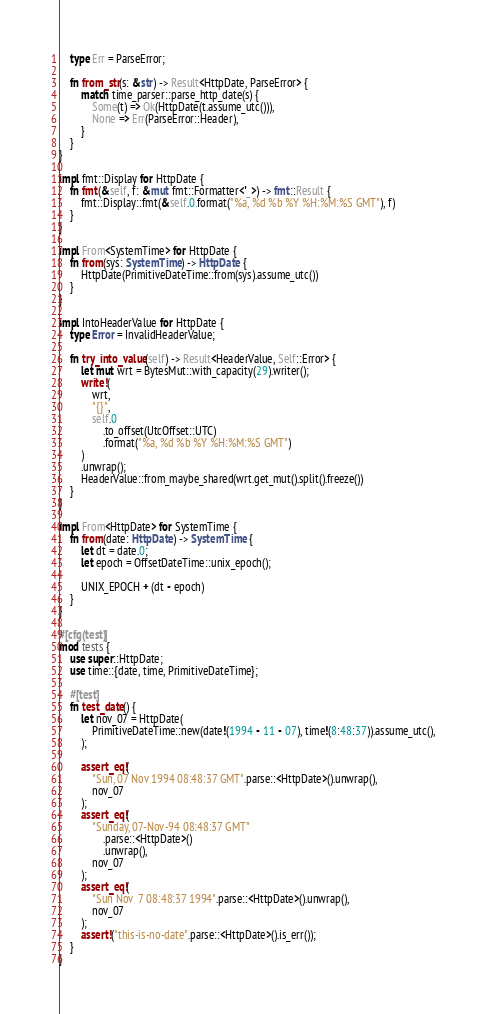<code> <loc_0><loc_0><loc_500><loc_500><_Rust_>    type Err = ParseError;

    fn from_str(s: &str) -> Result<HttpDate, ParseError> {
        match time_parser::parse_http_date(s) {
            Some(t) => Ok(HttpDate(t.assume_utc())),
            None => Err(ParseError::Header),
        }
    }
}

impl fmt::Display for HttpDate {
    fn fmt(&self, f: &mut fmt::Formatter<'_>) -> fmt::Result {
        fmt::Display::fmt(&self.0.format("%a, %d %b %Y %H:%M:%S GMT"), f)
    }
}

impl From<SystemTime> for HttpDate {
    fn from(sys: SystemTime) -> HttpDate {
        HttpDate(PrimitiveDateTime::from(sys).assume_utc())
    }
}

impl IntoHeaderValue for HttpDate {
    type Error = InvalidHeaderValue;

    fn try_into_value(self) -> Result<HeaderValue, Self::Error> {
        let mut wrt = BytesMut::with_capacity(29).writer();
        write!(
            wrt,
            "{}",
            self.0
                .to_offset(UtcOffset::UTC)
                .format("%a, %d %b %Y %H:%M:%S GMT")
        )
        .unwrap();
        HeaderValue::from_maybe_shared(wrt.get_mut().split().freeze())
    }
}

impl From<HttpDate> for SystemTime {
    fn from(date: HttpDate) -> SystemTime {
        let dt = date.0;
        let epoch = OffsetDateTime::unix_epoch();

        UNIX_EPOCH + (dt - epoch)
    }
}

#[cfg(test)]
mod tests {
    use super::HttpDate;
    use time::{date, time, PrimitiveDateTime};

    #[test]
    fn test_date() {
        let nov_07 = HttpDate(
            PrimitiveDateTime::new(date!(1994 - 11 - 07), time!(8:48:37)).assume_utc(),
        );

        assert_eq!(
            "Sun, 07 Nov 1994 08:48:37 GMT".parse::<HttpDate>().unwrap(),
            nov_07
        );
        assert_eq!(
            "Sunday, 07-Nov-94 08:48:37 GMT"
                .parse::<HttpDate>()
                .unwrap(),
            nov_07
        );
        assert_eq!(
            "Sun Nov  7 08:48:37 1994".parse::<HttpDate>().unwrap(),
            nov_07
        );
        assert!("this-is-no-date".parse::<HttpDate>().is_err());
    }
}
</code> 